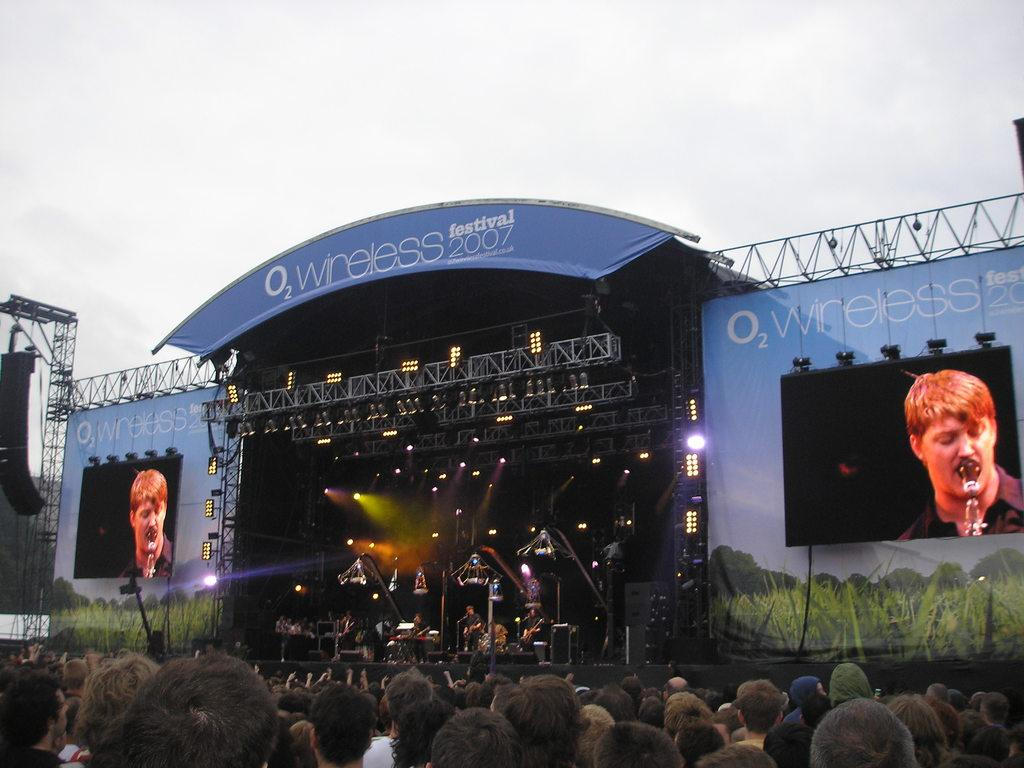What is happening in the image? There are people standing in the image, and there is a stage in the background where people are performing. What can be seen on the stage? People are performing on the stage. What additional elements are present in the image? There are screens, lights, banners, and speakers visible in the image. What is visible in the background of the image? The sky is visible in the image. What type of leaf is being used as a knee pad by the performers on stage? There is no leaf or knee pad visible in the image; the performers are not using any such items. 